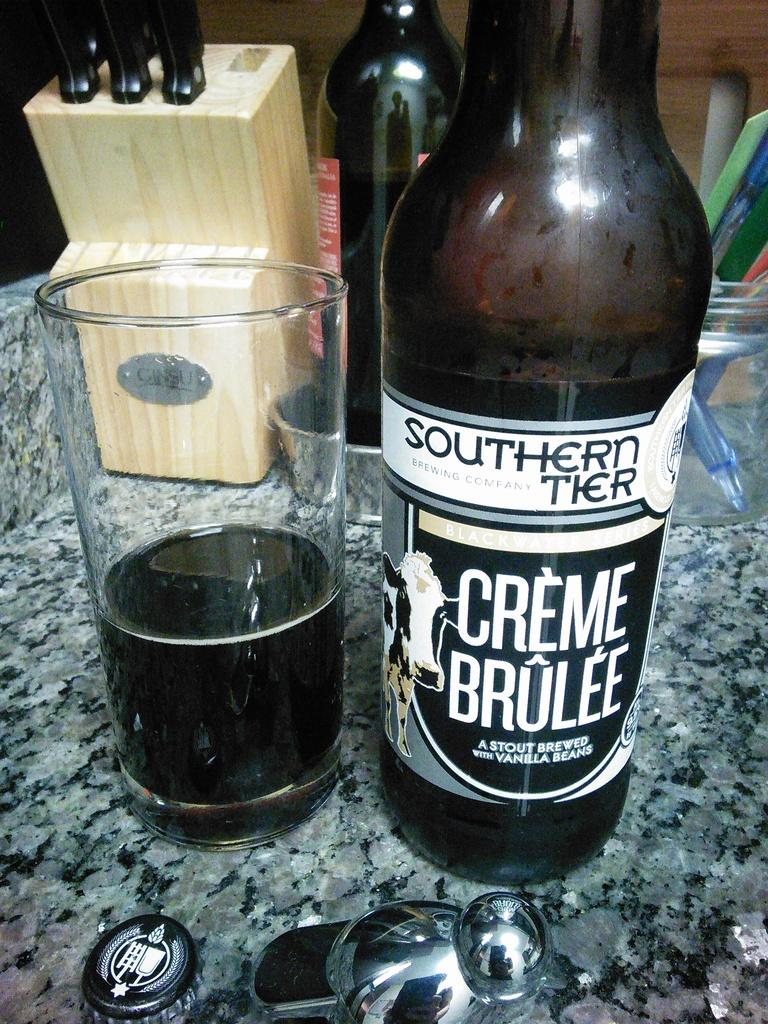<image>
Summarize the visual content of the image. A bottle of creme brulee beer has been brewed with vanilla beans. 